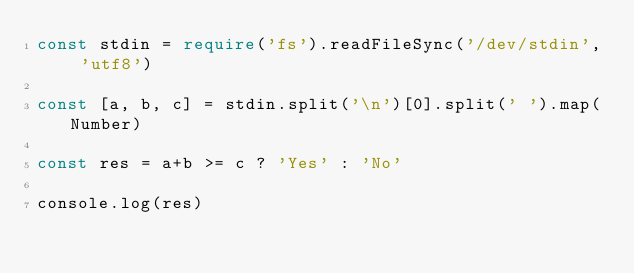Convert code to text. <code><loc_0><loc_0><loc_500><loc_500><_TypeScript_>const stdin = require('fs').readFileSync('/dev/stdin', 'utf8')

const [a, b, c] = stdin.split('\n')[0].split(' ').map(Number)

const res = a+b >= c ? 'Yes' : 'No'

console.log(res)</code> 